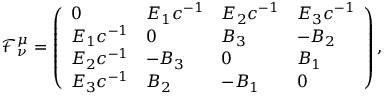Convert formula to latex. <formula><loc_0><loc_0><loc_500><loc_500>\mathcal { F } ^ { \mu } _ { \nu } = \left ( \begin{array} { l l l l } { 0 } & { E _ { 1 } c ^ { - 1 } } & { E _ { 2 } c ^ { - 1 } } & { E _ { 3 } c ^ { - 1 } } \\ { E _ { 1 } c ^ { - 1 } } & { 0 } & { B _ { 3 } } & { - B _ { 2 } } \\ { E _ { 2 } c ^ { - 1 } } & { - B _ { 3 } } & { 0 } & { B _ { 1 } } \\ { E _ { 3 } c ^ { - 1 } } & { B _ { 2 } } & { - B _ { 1 } } & { 0 } \end{array} \right ) ,</formula> 